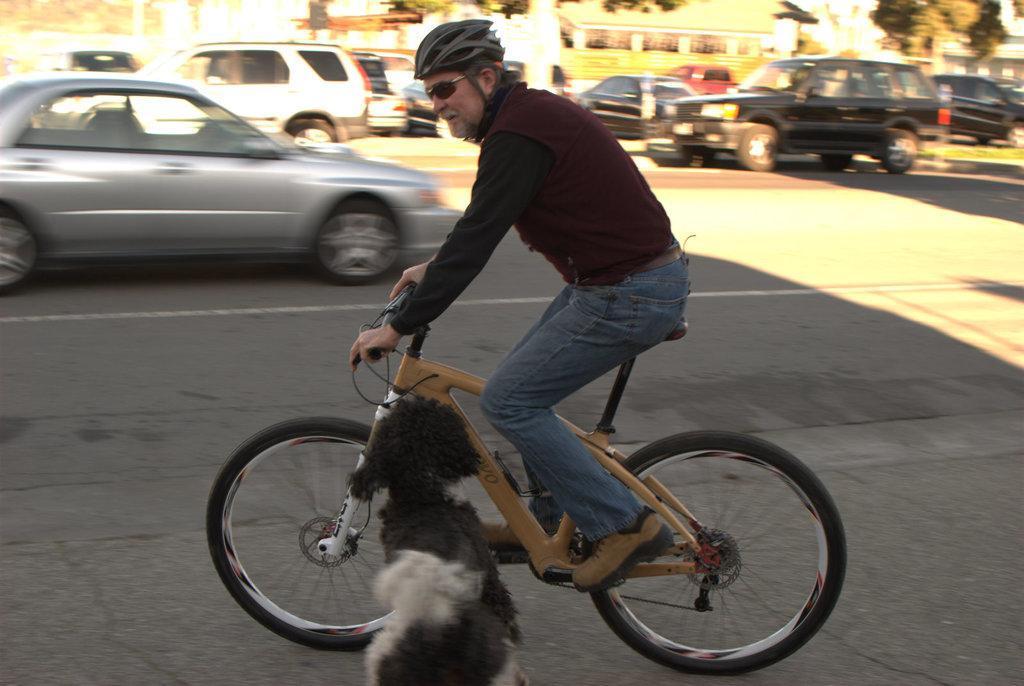Could you give a brief overview of what you see in this image? This is on road. A old man riding a bicycle wearing a helmet,in front of him there is a puppy and back side of him there is a car and over total background there are many cars trees and building. 